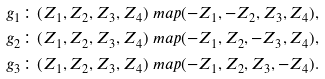Convert formula to latex. <formula><loc_0><loc_0><loc_500><loc_500>g _ { 1 } \colon ( Z _ { 1 } , Z _ { 2 } , Z _ { 3 } , Z _ { 4 } ) & \ m a p ( - Z _ { 1 } , - Z _ { 2 } , Z _ { 3 } , Z _ { 4 } ) , \\ g _ { 2 } \colon ( Z _ { 1 } , Z _ { 2 } , Z _ { 3 } , Z _ { 4 } ) & \ m a p ( - Z _ { 1 } , Z _ { 2 } , - Z _ { 3 } , Z _ { 4 } ) , \\ g _ { 3 } \colon ( Z _ { 1 } , Z _ { 2 } , Z _ { 3 } , Z _ { 4 } ) & \ m a p ( - Z _ { 1 } , Z _ { 2 } , Z _ { 3 } , - Z _ { 4 } ) .</formula> 